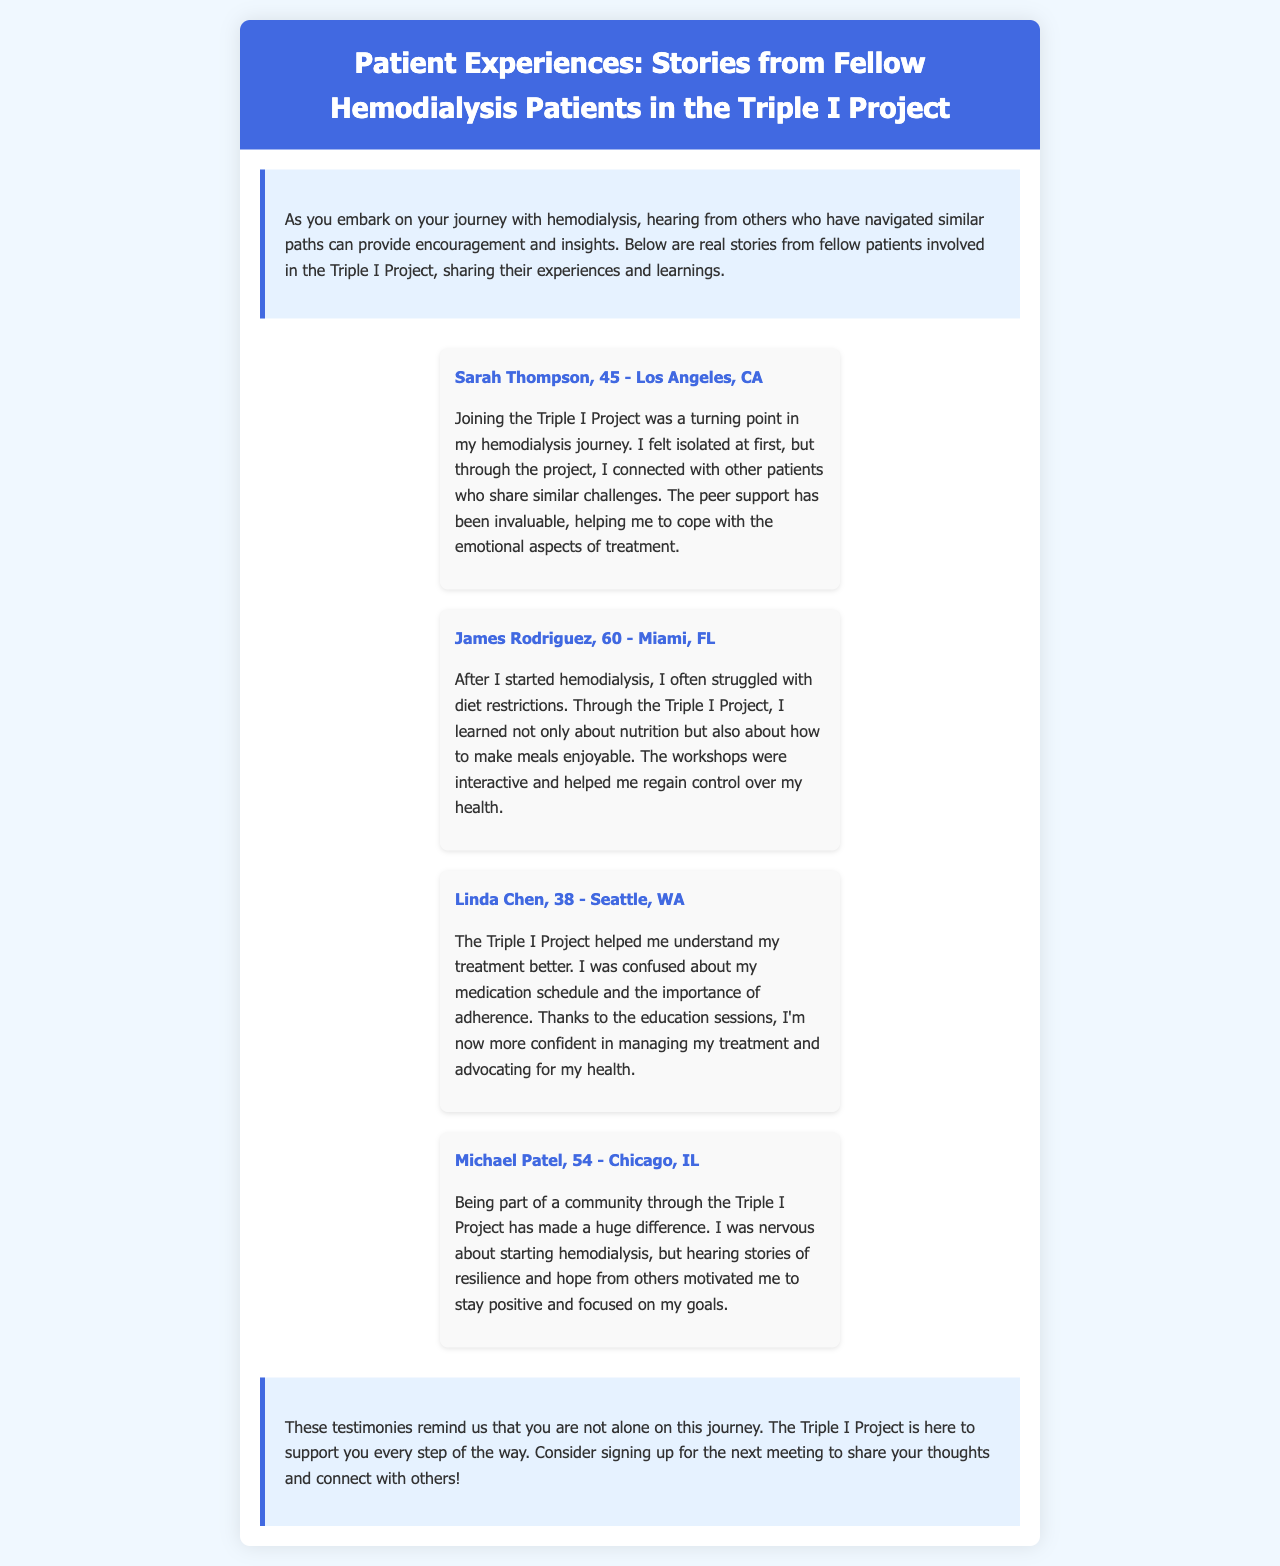What is the title of the newsletter? The title of the newsletter is found at the top of the document, which summarizes the content.
Answer: Patient Experiences: Stories from Fellow Hemodialysis Patients in the Triple I Project Who is the first patient mentioned in the testimonials? The first patient mentioned in the testimonials is listed in the first testimonial section of the document.
Answer: Sarah Thompson How old is James Rodriguez? James Rodriguez's age is stated directly in his testimonial segment.
Answer: 60 What city is Linda Chen from? The city where Linda Chen resides is indicated in her testimonial.
Answer: Seattle, WA What is one benefit mentioned by Sarah Thompson about the Triple I Project? Sarah Thompson describes a specific benefit in her description of the project's impact on her life.
Answer: Peer support How did the Triple I Project help Michael Patel? The document outlines how Michael felt before and after joining the project, detailing a significant change.
Answer: Community What theme connects the testimonials shared in the document? The document highlights a recurring theme among all patients' experiences in the testimonials.
Answer: Support What does the newsletter encourage patients to do? The closing section of the newsletter recommends a particular action for patients.
Answer: Sign up for the next meeting 